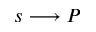Convert formula to latex. <formula><loc_0><loc_0><loc_500><loc_500>s \longrightarrow P</formula> 